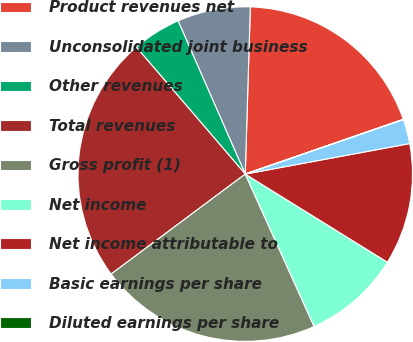Convert chart. <chart><loc_0><loc_0><loc_500><loc_500><pie_chart><fcel>Product revenues net<fcel>Unconsolidated joint business<fcel>Other revenues<fcel>Total revenues<fcel>Gross profit (1)<fcel>Net income<fcel>Net income attributable to<fcel>Basic earnings per share<fcel>Diluted earnings per share<nl><fcel>19.21%<fcel>7.06%<fcel>4.71%<fcel>23.91%<fcel>21.56%<fcel>9.41%<fcel>11.75%<fcel>2.37%<fcel>0.02%<nl></chart> 